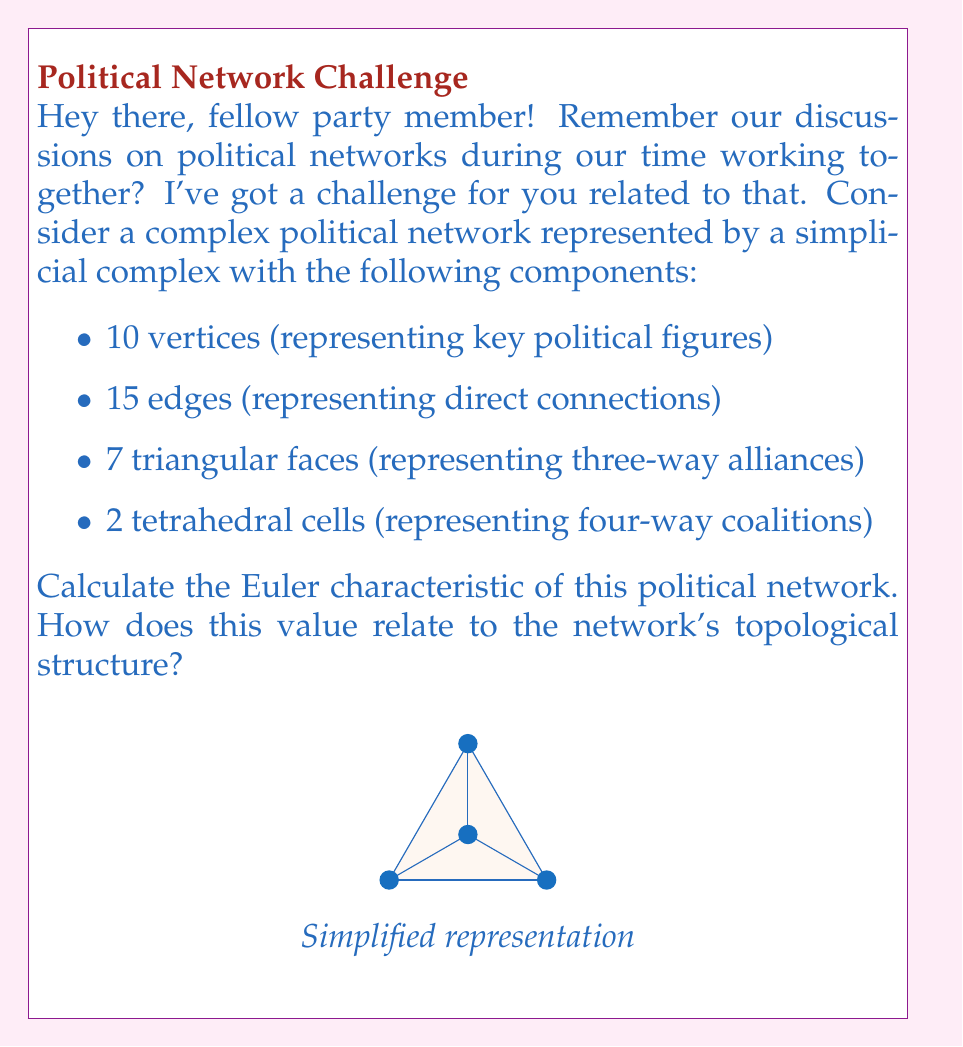What is the answer to this math problem? Let's approach this step-by-step using the Euler characteristic formula for simplicial complexes:

1) The Euler characteristic $\chi$ is given by the alternating sum of the number of simplices in each dimension:

   $$\chi = \sum_{i=0}^{\infty} (-1)^i n_i$$

   where $n_i$ is the number of $i$-dimensional simplices.

2) In our case:
   - $n_0 = 10$ (vertices, 0-simplices)
   - $n_1 = 15$ (edges, 1-simplices)
   - $n_2 = 7$ (triangular faces, 2-simplices)
   - $n_3 = 2$ (tetrahedral cells, 3-simplices)
   - $n_i = 0$ for $i \geq 4$

3) Substituting into the formula:

   $$\chi = n_0 - n_1 + n_2 - n_3$$
   $$\chi = 10 - 15 + 7 - 2$$

4) Calculating:

   $$\chi = 0$$

5) Interpretation: The Euler characteristic of 0 suggests that this political network has a complex topology. In general:
   - A positive $\chi$ often indicates a disconnected or sphere-like structure.
   - A negative $\chi$ can suggest a network with many holes or a high genus.
   - $\chi = 0$ can occur in torus-like structures or more complex balanced networks.

   In this case, the zero Euler characteristic implies that the political network has a balanced structure between its various components, potentially indicating a complex web of alliances and coalitions that neither simplifies to a basic structure nor expands into a highly convoluted one.
Answer: $\chi = 0$ 